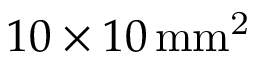<formula> <loc_0><loc_0><loc_500><loc_500>1 0 \times 1 0 \, m m ^ { 2 }</formula> 